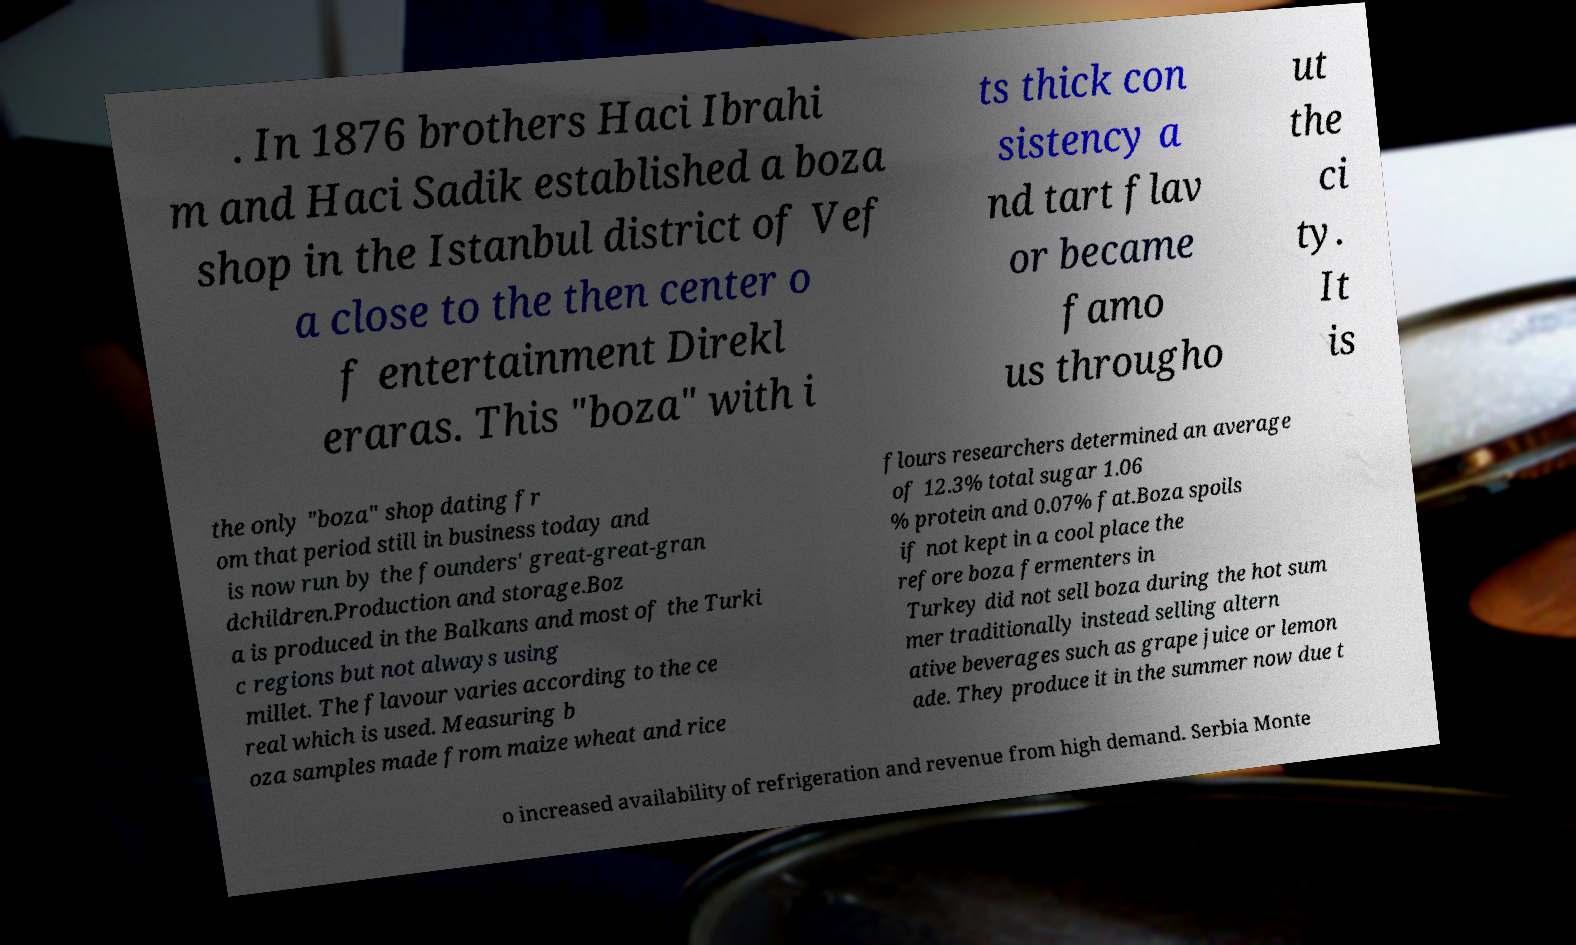Please read and relay the text visible in this image. What does it say? . In 1876 brothers Haci Ibrahi m and Haci Sadik established a boza shop in the Istanbul district of Vef a close to the then center o f entertainment Direkl eraras. This "boza" with i ts thick con sistency a nd tart flav or became famo us througho ut the ci ty. It is the only "boza" shop dating fr om that period still in business today and is now run by the founders' great-great-gran dchildren.Production and storage.Boz a is produced in the Balkans and most of the Turki c regions but not always using millet. The flavour varies according to the ce real which is used. Measuring b oza samples made from maize wheat and rice flours researchers determined an average of 12.3% total sugar 1.06 % protein and 0.07% fat.Boza spoils if not kept in a cool place the refore boza fermenters in Turkey did not sell boza during the hot sum mer traditionally instead selling altern ative beverages such as grape juice or lemon ade. They produce it in the summer now due t o increased availability of refrigeration and revenue from high demand. Serbia Monte 